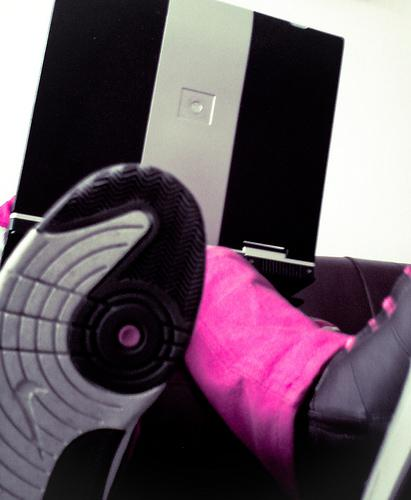Question: what color are the shoelaces?
Choices:
A. White.
B. Pink.
C. Black.
D. Yellow.
Answer with the letter. Answer: B Question: what type of computer is in the photo?
Choices:
A. Desktop.
B. Windows.
C. Laptop.
D. Macbook.
Answer with the letter. Answer: C Question: what brand of shoes is the person wearing?
Choices:
A. Nike.
B. Puma.
C. Toms.
D. Keds.
Answer with the letter. Answer: A Question: how many shoes are in the picture?
Choices:
A. 4.
B. 6.
C. 2.
D. 12.
Answer with the letter. Answer: C Question: where is the computer?
Choices:
A. On lap.
B. On the table.
C. In the bag.
D. On the desk.
Answer with the letter. Answer: A Question: what color pants is the person wearing?
Choices:
A. Brown.
B. Black.
C. Green.
D. Pink.
Answer with the letter. Answer: D 